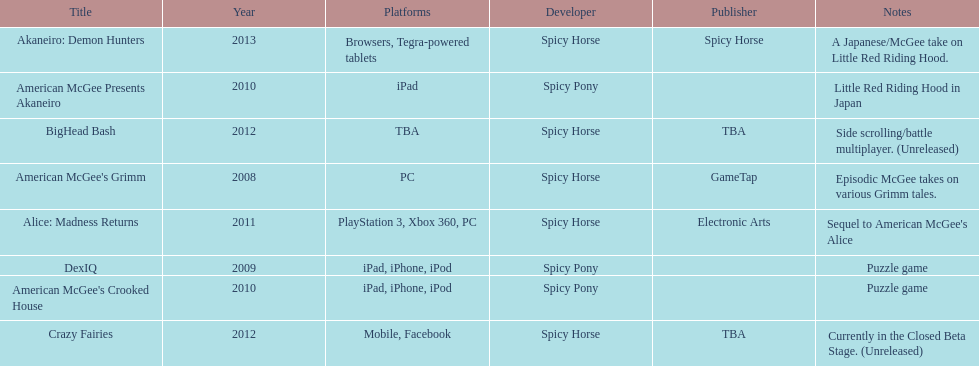Which title is for ipad but not for iphone or ipod? American McGee Presents Akaneiro. 